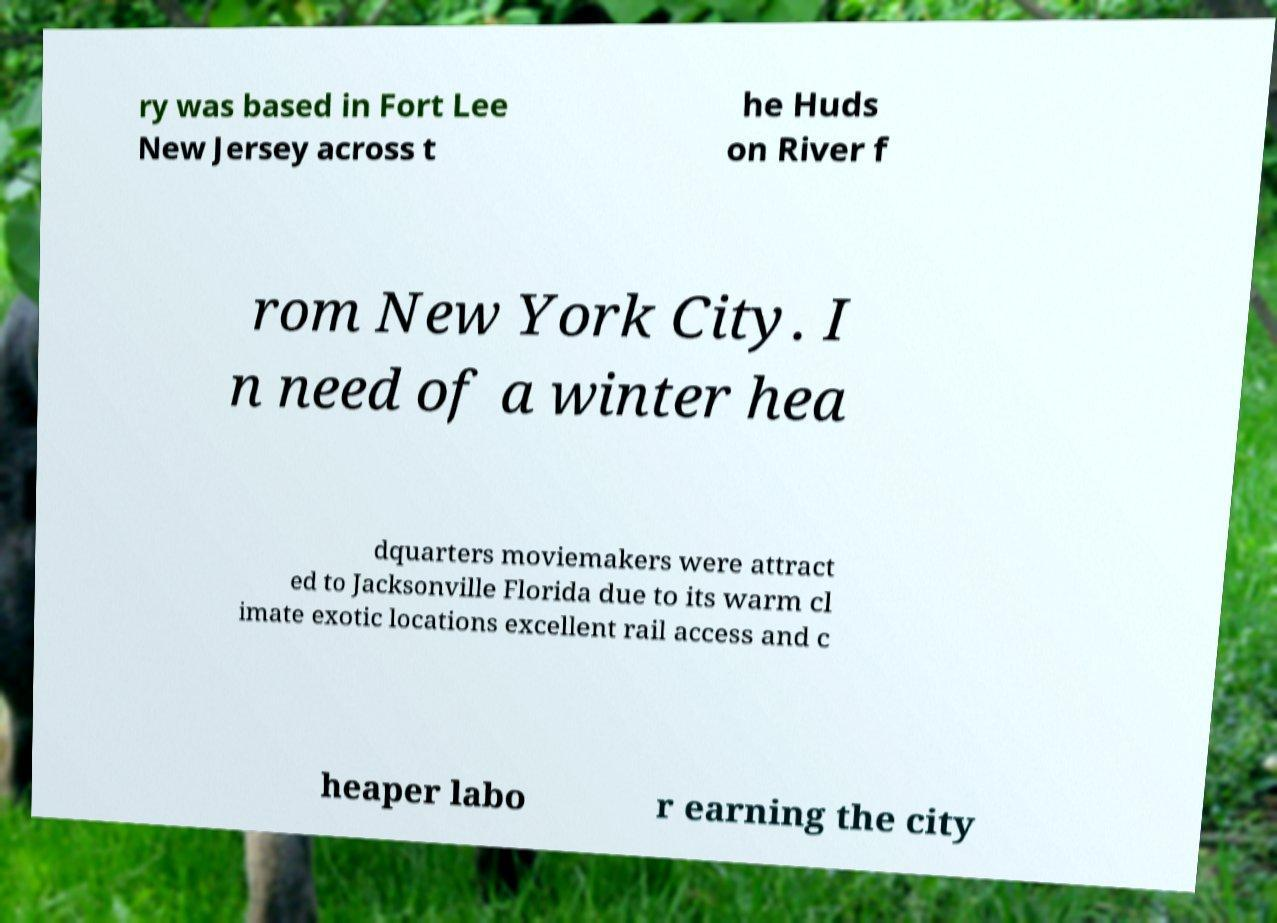Could you assist in decoding the text presented in this image and type it out clearly? ry was based in Fort Lee New Jersey across t he Huds on River f rom New York City. I n need of a winter hea dquarters moviemakers were attract ed to Jacksonville Florida due to its warm cl imate exotic locations excellent rail access and c heaper labo r earning the city 